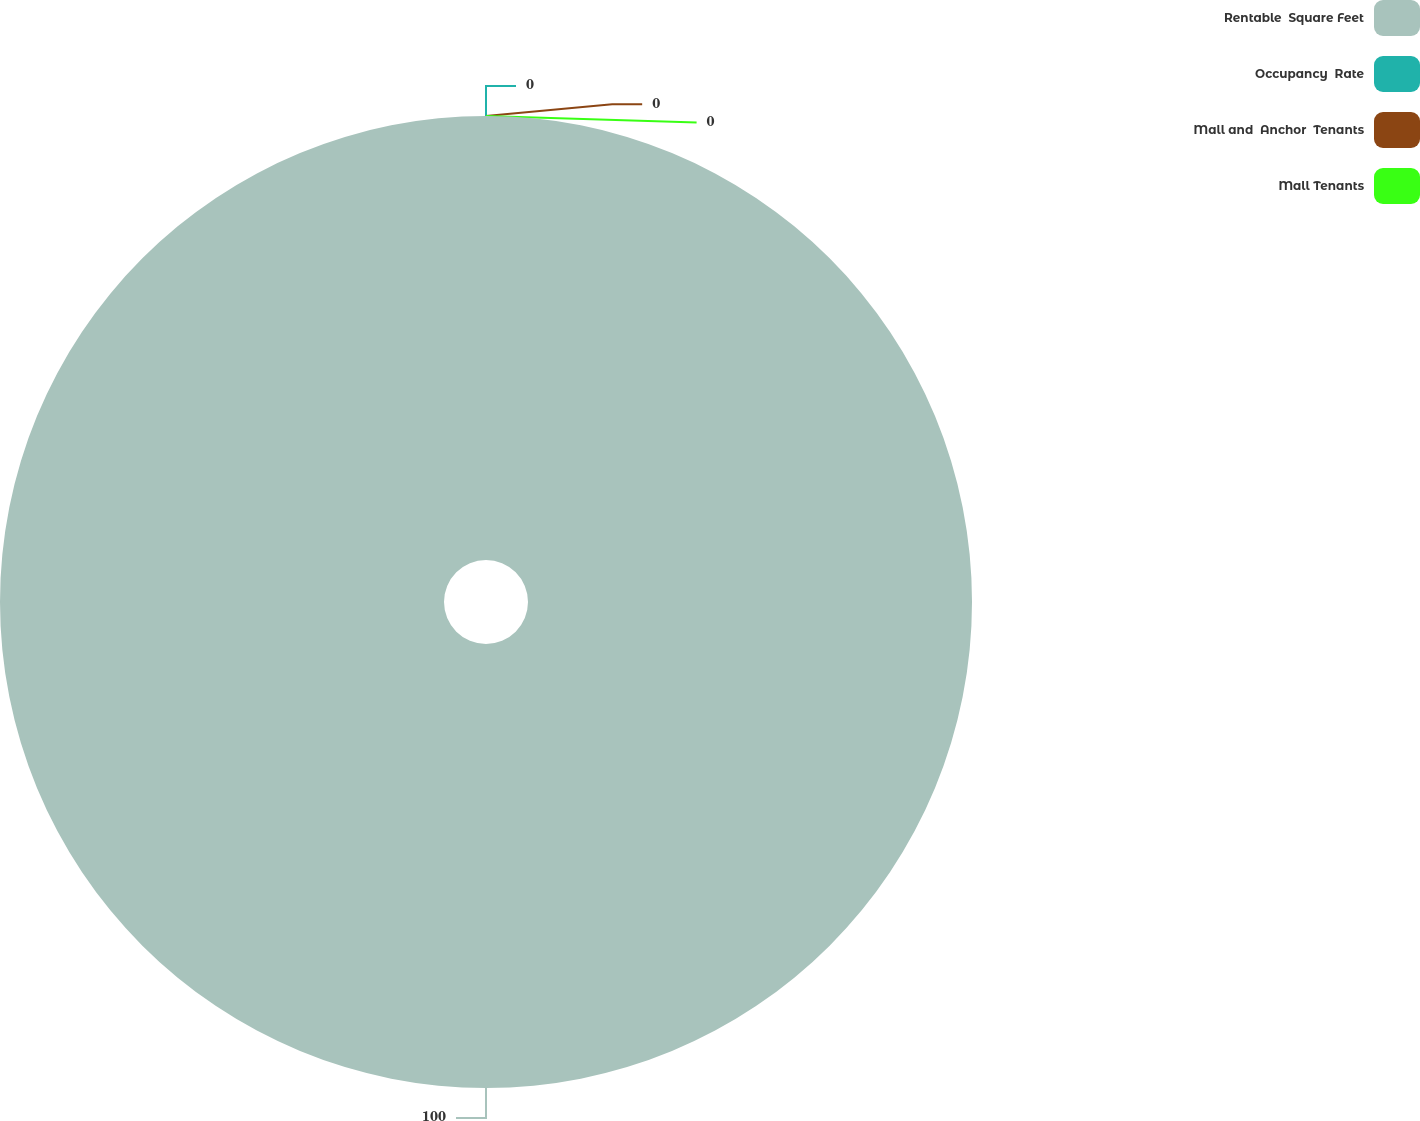Convert chart. <chart><loc_0><loc_0><loc_500><loc_500><pie_chart><fcel>Rentable  Square Feet<fcel>Occupancy  Rate<fcel>Mall and  Anchor  Tenants<fcel>Mall Tenants<nl><fcel>100.0%<fcel>0.0%<fcel>0.0%<fcel>0.0%<nl></chart> 